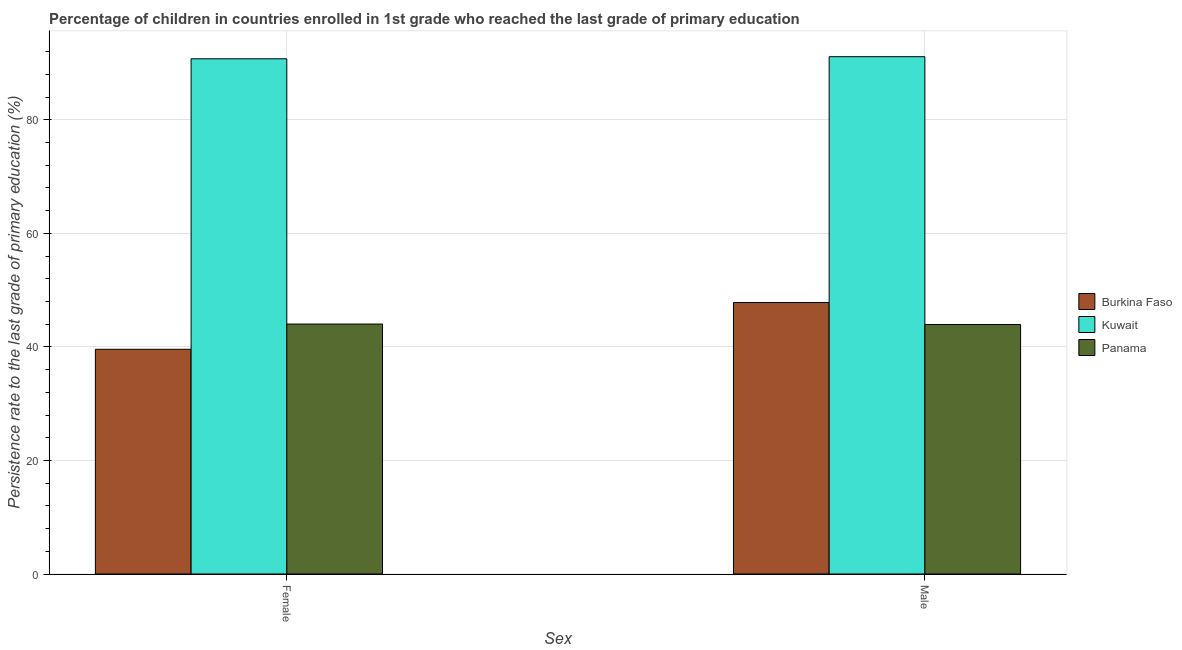How many different coloured bars are there?
Keep it short and to the point. 3. How many groups of bars are there?
Provide a short and direct response. 2. Are the number of bars per tick equal to the number of legend labels?
Offer a terse response. Yes. What is the label of the 2nd group of bars from the left?
Provide a short and direct response. Male. What is the persistence rate of male students in Burkina Faso?
Keep it short and to the point. 47.81. Across all countries, what is the maximum persistence rate of male students?
Ensure brevity in your answer.  91.1. Across all countries, what is the minimum persistence rate of female students?
Your answer should be very brief. 39.57. In which country was the persistence rate of male students maximum?
Your answer should be compact. Kuwait. In which country was the persistence rate of male students minimum?
Your answer should be compact. Panama. What is the total persistence rate of female students in the graph?
Offer a very short reply. 174.33. What is the difference between the persistence rate of male students in Kuwait and that in Panama?
Your answer should be compact. 47.16. What is the difference between the persistence rate of male students in Panama and the persistence rate of female students in Burkina Faso?
Make the answer very short. 4.37. What is the average persistence rate of female students per country?
Provide a short and direct response. 58.11. What is the difference between the persistence rate of female students and persistence rate of male students in Panama?
Give a very brief answer. 0.08. In how many countries, is the persistence rate of female students greater than 12 %?
Provide a short and direct response. 3. What is the ratio of the persistence rate of female students in Kuwait to that in Burkina Faso?
Provide a succinct answer. 2.29. What does the 1st bar from the left in Male represents?
Provide a succinct answer. Burkina Faso. What does the 3rd bar from the right in Male represents?
Make the answer very short. Burkina Faso. What is the difference between two consecutive major ticks on the Y-axis?
Give a very brief answer. 20. Are the values on the major ticks of Y-axis written in scientific E-notation?
Offer a very short reply. No. Does the graph contain grids?
Provide a succinct answer. Yes. Where does the legend appear in the graph?
Offer a very short reply. Center right. What is the title of the graph?
Ensure brevity in your answer.  Percentage of children in countries enrolled in 1st grade who reached the last grade of primary education. What is the label or title of the X-axis?
Make the answer very short. Sex. What is the label or title of the Y-axis?
Ensure brevity in your answer.  Persistence rate to the last grade of primary education (%). What is the Persistence rate to the last grade of primary education (%) of Burkina Faso in Female?
Provide a succinct answer. 39.57. What is the Persistence rate to the last grade of primary education (%) of Kuwait in Female?
Give a very brief answer. 90.74. What is the Persistence rate to the last grade of primary education (%) of Panama in Female?
Offer a very short reply. 44.02. What is the Persistence rate to the last grade of primary education (%) in Burkina Faso in Male?
Offer a very short reply. 47.81. What is the Persistence rate to the last grade of primary education (%) of Kuwait in Male?
Your response must be concise. 91.1. What is the Persistence rate to the last grade of primary education (%) of Panama in Male?
Provide a short and direct response. 43.94. Across all Sex, what is the maximum Persistence rate to the last grade of primary education (%) of Burkina Faso?
Your answer should be compact. 47.81. Across all Sex, what is the maximum Persistence rate to the last grade of primary education (%) of Kuwait?
Offer a terse response. 91.1. Across all Sex, what is the maximum Persistence rate to the last grade of primary education (%) of Panama?
Provide a short and direct response. 44.02. Across all Sex, what is the minimum Persistence rate to the last grade of primary education (%) of Burkina Faso?
Your response must be concise. 39.57. Across all Sex, what is the minimum Persistence rate to the last grade of primary education (%) of Kuwait?
Your response must be concise. 90.74. Across all Sex, what is the minimum Persistence rate to the last grade of primary education (%) of Panama?
Make the answer very short. 43.94. What is the total Persistence rate to the last grade of primary education (%) of Burkina Faso in the graph?
Ensure brevity in your answer.  87.38. What is the total Persistence rate to the last grade of primary education (%) of Kuwait in the graph?
Your answer should be very brief. 181.84. What is the total Persistence rate to the last grade of primary education (%) in Panama in the graph?
Give a very brief answer. 87.96. What is the difference between the Persistence rate to the last grade of primary education (%) of Burkina Faso in Female and that in Male?
Your answer should be very brief. -8.23. What is the difference between the Persistence rate to the last grade of primary education (%) in Kuwait in Female and that in Male?
Offer a terse response. -0.37. What is the difference between the Persistence rate to the last grade of primary education (%) of Panama in Female and that in Male?
Provide a succinct answer. 0.08. What is the difference between the Persistence rate to the last grade of primary education (%) in Burkina Faso in Female and the Persistence rate to the last grade of primary education (%) in Kuwait in Male?
Your answer should be very brief. -51.53. What is the difference between the Persistence rate to the last grade of primary education (%) in Burkina Faso in Female and the Persistence rate to the last grade of primary education (%) in Panama in Male?
Provide a succinct answer. -4.37. What is the difference between the Persistence rate to the last grade of primary education (%) of Kuwait in Female and the Persistence rate to the last grade of primary education (%) of Panama in Male?
Ensure brevity in your answer.  46.79. What is the average Persistence rate to the last grade of primary education (%) in Burkina Faso per Sex?
Ensure brevity in your answer.  43.69. What is the average Persistence rate to the last grade of primary education (%) in Kuwait per Sex?
Your answer should be very brief. 90.92. What is the average Persistence rate to the last grade of primary education (%) of Panama per Sex?
Ensure brevity in your answer.  43.98. What is the difference between the Persistence rate to the last grade of primary education (%) in Burkina Faso and Persistence rate to the last grade of primary education (%) in Kuwait in Female?
Your answer should be very brief. -51.16. What is the difference between the Persistence rate to the last grade of primary education (%) of Burkina Faso and Persistence rate to the last grade of primary education (%) of Panama in Female?
Your answer should be very brief. -4.45. What is the difference between the Persistence rate to the last grade of primary education (%) of Kuwait and Persistence rate to the last grade of primary education (%) of Panama in Female?
Your response must be concise. 46.71. What is the difference between the Persistence rate to the last grade of primary education (%) of Burkina Faso and Persistence rate to the last grade of primary education (%) of Kuwait in Male?
Make the answer very short. -43.3. What is the difference between the Persistence rate to the last grade of primary education (%) in Burkina Faso and Persistence rate to the last grade of primary education (%) in Panama in Male?
Offer a terse response. 3.87. What is the difference between the Persistence rate to the last grade of primary education (%) in Kuwait and Persistence rate to the last grade of primary education (%) in Panama in Male?
Offer a very short reply. 47.16. What is the ratio of the Persistence rate to the last grade of primary education (%) in Burkina Faso in Female to that in Male?
Your answer should be compact. 0.83. What is the ratio of the Persistence rate to the last grade of primary education (%) in Kuwait in Female to that in Male?
Your response must be concise. 1. What is the difference between the highest and the second highest Persistence rate to the last grade of primary education (%) in Burkina Faso?
Your answer should be compact. 8.23. What is the difference between the highest and the second highest Persistence rate to the last grade of primary education (%) in Kuwait?
Your answer should be compact. 0.37. What is the difference between the highest and the second highest Persistence rate to the last grade of primary education (%) in Panama?
Offer a very short reply. 0.08. What is the difference between the highest and the lowest Persistence rate to the last grade of primary education (%) of Burkina Faso?
Your answer should be very brief. 8.23. What is the difference between the highest and the lowest Persistence rate to the last grade of primary education (%) of Kuwait?
Offer a terse response. 0.37. What is the difference between the highest and the lowest Persistence rate to the last grade of primary education (%) in Panama?
Keep it short and to the point. 0.08. 